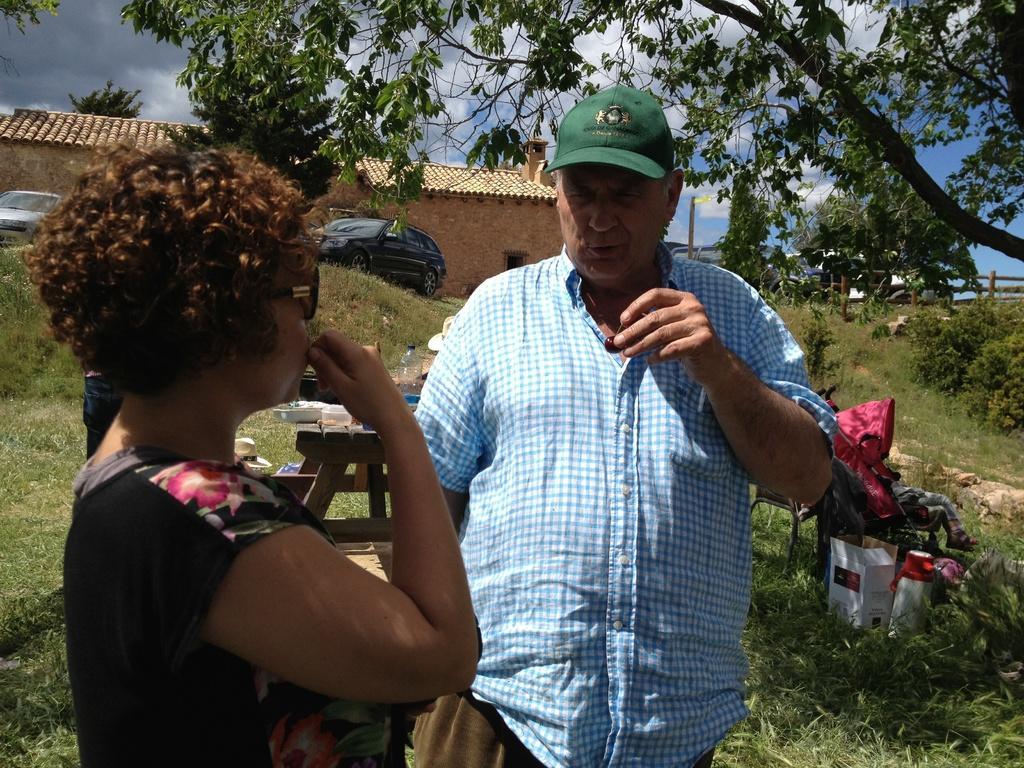Describe this image in one or two sentences. In this image I can see two persons standing. The person in front wearing black color dress and the other person is wearing blue and white color shirt. Background I can see few vehicles, a house in brown color, trees in green color and sky in blue and white color. 